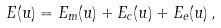<formula> <loc_0><loc_0><loc_500><loc_500>E ( u ) = E _ { m } ( u ) + E _ { c } ( u ) + E _ { e } ( u ) \, ,</formula> 